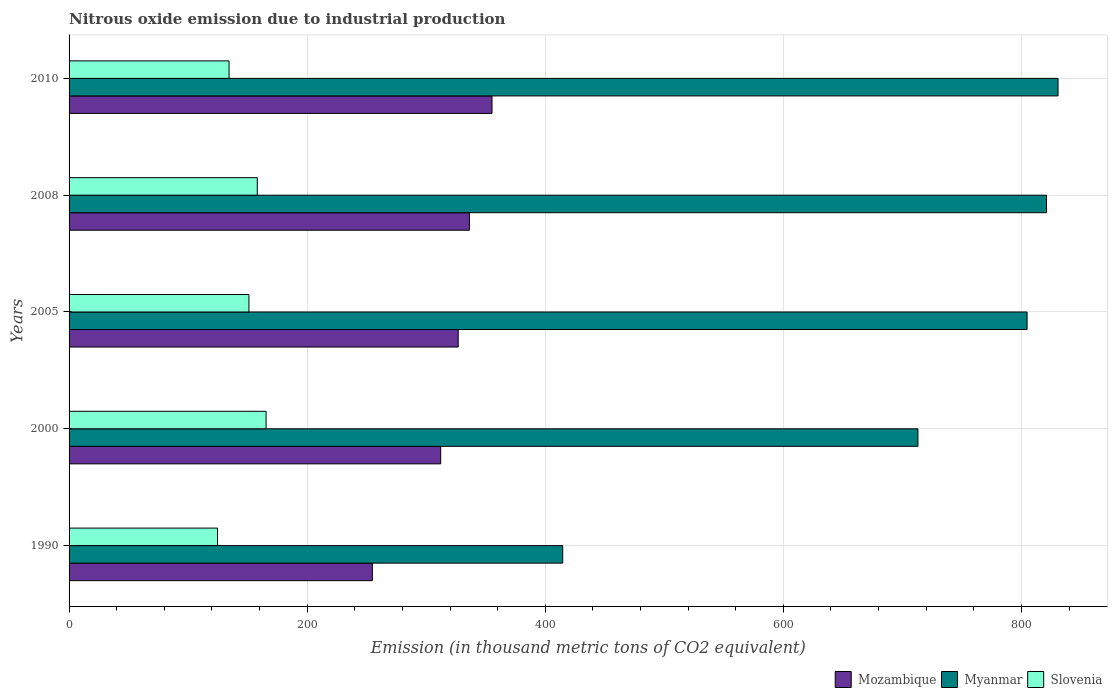How many groups of bars are there?
Your response must be concise. 5. Are the number of bars on each tick of the Y-axis equal?
Provide a short and direct response. Yes. What is the label of the 1st group of bars from the top?
Offer a very short reply. 2010. What is the amount of nitrous oxide emitted in Mozambique in 2005?
Ensure brevity in your answer.  326.9. Across all years, what is the maximum amount of nitrous oxide emitted in Slovenia?
Provide a succinct answer. 165.5. Across all years, what is the minimum amount of nitrous oxide emitted in Myanmar?
Keep it short and to the point. 414.7. In which year was the amount of nitrous oxide emitted in Slovenia maximum?
Your answer should be compact. 2000. In which year was the amount of nitrous oxide emitted in Slovenia minimum?
Your answer should be compact. 1990. What is the total amount of nitrous oxide emitted in Slovenia in the graph?
Your response must be concise. 733.8. What is the difference between the amount of nitrous oxide emitted in Mozambique in 2000 and that in 2008?
Make the answer very short. -24.1. What is the difference between the amount of nitrous oxide emitted in Myanmar in 1990 and the amount of nitrous oxide emitted in Mozambique in 2000?
Your response must be concise. 102.5. What is the average amount of nitrous oxide emitted in Mozambique per year?
Offer a terse response. 317.1. In the year 2005, what is the difference between the amount of nitrous oxide emitted in Slovenia and amount of nitrous oxide emitted in Mozambique?
Keep it short and to the point. -175.8. What is the ratio of the amount of nitrous oxide emitted in Mozambique in 1990 to that in 2008?
Your response must be concise. 0.76. Is the amount of nitrous oxide emitted in Myanmar in 1990 less than that in 2000?
Keep it short and to the point. Yes. Is the difference between the amount of nitrous oxide emitted in Slovenia in 2000 and 2010 greater than the difference between the amount of nitrous oxide emitted in Mozambique in 2000 and 2010?
Offer a very short reply. Yes. What is the difference between the highest and the second highest amount of nitrous oxide emitted in Myanmar?
Your answer should be compact. 9.7. What is the difference between the highest and the lowest amount of nitrous oxide emitted in Slovenia?
Give a very brief answer. 40.8. In how many years, is the amount of nitrous oxide emitted in Slovenia greater than the average amount of nitrous oxide emitted in Slovenia taken over all years?
Your response must be concise. 3. What does the 3rd bar from the top in 2000 represents?
Give a very brief answer. Mozambique. What does the 1st bar from the bottom in 1990 represents?
Your response must be concise. Mozambique. Is it the case that in every year, the sum of the amount of nitrous oxide emitted in Mozambique and amount of nitrous oxide emitted in Myanmar is greater than the amount of nitrous oxide emitted in Slovenia?
Your answer should be very brief. Yes. How many bars are there?
Offer a very short reply. 15. Are all the bars in the graph horizontal?
Keep it short and to the point. Yes. What is the difference between two consecutive major ticks on the X-axis?
Ensure brevity in your answer.  200. Are the values on the major ticks of X-axis written in scientific E-notation?
Offer a terse response. No. How many legend labels are there?
Your response must be concise. 3. What is the title of the graph?
Your answer should be compact. Nitrous oxide emission due to industrial production. What is the label or title of the X-axis?
Your response must be concise. Emission (in thousand metric tons of CO2 equivalent). What is the Emission (in thousand metric tons of CO2 equivalent) in Mozambique in 1990?
Your answer should be very brief. 254.8. What is the Emission (in thousand metric tons of CO2 equivalent) in Myanmar in 1990?
Keep it short and to the point. 414.7. What is the Emission (in thousand metric tons of CO2 equivalent) in Slovenia in 1990?
Make the answer very short. 124.7. What is the Emission (in thousand metric tons of CO2 equivalent) in Mozambique in 2000?
Your answer should be very brief. 312.2. What is the Emission (in thousand metric tons of CO2 equivalent) of Myanmar in 2000?
Provide a succinct answer. 713.1. What is the Emission (in thousand metric tons of CO2 equivalent) of Slovenia in 2000?
Give a very brief answer. 165.5. What is the Emission (in thousand metric tons of CO2 equivalent) in Mozambique in 2005?
Ensure brevity in your answer.  326.9. What is the Emission (in thousand metric tons of CO2 equivalent) of Myanmar in 2005?
Ensure brevity in your answer.  804.8. What is the Emission (in thousand metric tons of CO2 equivalent) of Slovenia in 2005?
Offer a very short reply. 151.1. What is the Emission (in thousand metric tons of CO2 equivalent) of Mozambique in 2008?
Your response must be concise. 336.3. What is the Emission (in thousand metric tons of CO2 equivalent) of Myanmar in 2008?
Give a very brief answer. 821.1. What is the Emission (in thousand metric tons of CO2 equivalent) of Slovenia in 2008?
Give a very brief answer. 158.1. What is the Emission (in thousand metric tons of CO2 equivalent) of Mozambique in 2010?
Your response must be concise. 355.3. What is the Emission (in thousand metric tons of CO2 equivalent) in Myanmar in 2010?
Your answer should be compact. 830.8. What is the Emission (in thousand metric tons of CO2 equivalent) of Slovenia in 2010?
Offer a very short reply. 134.4. Across all years, what is the maximum Emission (in thousand metric tons of CO2 equivalent) of Mozambique?
Offer a terse response. 355.3. Across all years, what is the maximum Emission (in thousand metric tons of CO2 equivalent) of Myanmar?
Keep it short and to the point. 830.8. Across all years, what is the maximum Emission (in thousand metric tons of CO2 equivalent) in Slovenia?
Your response must be concise. 165.5. Across all years, what is the minimum Emission (in thousand metric tons of CO2 equivalent) of Mozambique?
Your answer should be compact. 254.8. Across all years, what is the minimum Emission (in thousand metric tons of CO2 equivalent) of Myanmar?
Provide a short and direct response. 414.7. Across all years, what is the minimum Emission (in thousand metric tons of CO2 equivalent) in Slovenia?
Your response must be concise. 124.7. What is the total Emission (in thousand metric tons of CO2 equivalent) of Mozambique in the graph?
Give a very brief answer. 1585.5. What is the total Emission (in thousand metric tons of CO2 equivalent) of Myanmar in the graph?
Give a very brief answer. 3584.5. What is the total Emission (in thousand metric tons of CO2 equivalent) of Slovenia in the graph?
Offer a very short reply. 733.8. What is the difference between the Emission (in thousand metric tons of CO2 equivalent) of Mozambique in 1990 and that in 2000?
Provide a short and direct response. -57.4. What is the difference between the Emission (in thousand metric tons of CO2 equivalent) in Myanmar in 1990 and that in 2000?
Keep it short and to the point. -298.4. What is the difference between the Emission (in thousand metric tons of CO2 equivalent) of Slovenia in 1990 and that in 2000?
Offer a very short reply. -40.8. What is the difference between the Emission (in thousand metric tons of CO2 equivalent) in Mozambique in 1990 and that in 2005?
Provide a succinct answer. -72.1. What is the difference between the Emission (in thousand metric tons of CO2 equivalent) in Myanmar in 1990 and that in 2005?
Offer a very short reply. -390.1. What is the difference between the Emission (in thousand metric tons of CO2 equivalent) of Slovenia in 1990 and that in 2005?
Your response must be concise. -26.4. What is the difference between the Emission (in thousand metric tons of CO2 equivalent) of Mozambique in 1990 and that in 2008?
Make the answer very short. -81.5. What is the difference between the Emission (in thousand metric tons of CO2 equivalent) of Myanmar in 1990 and that in 2008?
Ensure brevity in your answer.  -406.4. What is the difference between the Emission (in thousand metric tons of CO2 equivalent) of Slovenia in 1990 and that in 2008?
Offer a very short reply. -33.4. What is the difference between the Emission (in thousand metric tons of CO2 equivalent) of Mozambique in 1990 and that in 2010?
Your response must be concise. -100.5. What is the difference between the Emission (in thousand metric tons of CO2 equivalent) of Myanmar in 1990 and that in 2010?
Your answer should be very brief. -416.1. What is the difference between the Emission (in thousand metric tons of CO2 equivalent) of Slovenia in 1990 and that in 2010?
Keep it short and to the point. -9.7. What is the difference between the Emission (in thousand metric tons of CO2 equivalent) in Mozambique in 2000 and that in 2005?
Give a very brief answer. -14.7. What is the difference between the Emission (in thousand metric tons of CO2 equivalent) of Myanmar in 2000 and that in 2005?
Provide a short and direct response. -91.7. What is the difference between the Emission (in thousand metric tons of CO2 equivalent) of Mozambique in 2000 and that in 2008?
Offer a terse response. -24.1. What is the difference between the Emission (in thousand metric tons of CO2 equivalent) of Myanmar in 2000 and that in 2008?
Your response must be concise. -108. What is the difference between the Emission (in thousand metric tons of CO2 equivalent) in Mozambique in 2000 and that in 2010?
Give a very brief answer. -43.1. What is the difference between the Emission (in thousand metric tons of CO2 equivalent) in Myanmar in 2000 and that in 2010?
Offer a terse response. -117.7. What is the difference between the Emission (in thousand metric tons of CO2 equivalent) in Slovenia in 2000 and that in 2010?
Your response must be concise. 31.1. What is the difference between the Emission (in thousand metric tons of CO2 equivalent) in Mozambique in 2005 and that in 2008?
Provide a short and direct response. -9.4. What is the difference between the Emission (in thousand metric tons of CO2 equivalent) of Myanmar in 2005 and that in 2008?
Keep it short and to the point. -16.3. What is the difference between the Emission (in thousand metric tons of CO2 equivalent) in Mozambique in 2005 and that in 2010?
Offer a terse response. -28.4. What is the difference between the Emission (in thousand metric tons of CO2 equivalent) in Slovenia in 2005 and that in 2010?
Your answer should be compact. 16.7. What is the difference between the Emission (in thousand metric tons of CO2 equivalent) in Myanmar in 2008 and that in 2010?
Your answer should be very brief. -9.7. What is the difference between the Emission (in thousand metric tons of CO2 equivalent) of Slovenia in 2008 and that in 2010?
Provide a short and direct response. 23.7. What is the difference between the Emission (in thousand metric tons of CO2 equivalent) in Mozambique in 1990 and the Emission (in thousand metric tons of CO2 equivalent) in Myanmar in 2000?
Offer a terse response. -458.3. What is the difference between the Emission (in thousand metric tons of CO2 equivalent) in Mozambique in 1990 and the Emission (in thousand metric tons of CO2 equivalent) in Slovenia in 2000?
Keep it short and to the point. 89.3. What is the difference between the Emission (in thousand metric tons of CO2 equivalent) in Myanmar in 1990 and the Emission (in thousand metric tons of CO2 equivalent) in Slovenia in 2000?
Give a very brief answer. 249.2. What is the difference between the Emission (in thousand metric tons of CO2 equivalent) in Mozambique in 1990 and the Emission (in thousand metric tons of CO2 equivalent) in Myanmar in 2005?
Your answer should be compact. -550. What is the difference between the Emission (in thousand metric tons of CO2 equivalent) of Mozambique in 1990 and the Emission (in thousand metric tons of CO2 equivalent) of Slovenia in 2005?
Your answer should be very brief. 103.7. What is the difference between the Emission (in thousand metric tons of CO2 equivalent) of Myanmar in 1990 and the Emission (in thousand metric tons of CO2 equivalent) of Slovenia in 2005?
Give a very brief answer. 263.6. What is the difference between the Emission (in thousand metric tons of CO2 equivalent) in Mozambique in 1990 and the Emission (in thousand metric tons of CO2 equivalent) in Myanmar in 2008?
Offer a terse response. -566.3. What is the difference between the Emission (in thousand metric tons of CO2 equivalent) in Mozambique in 1990 and the Emission (in thousand metric tons of CO2 equivalent) in Slovenia in 2008?
Your response must be concise. 96.7. What is the difference between the Emission (in thousand metric tons of CO2 equivalent) of Myanmar in 1990 and the Emission (in thousand metric tons of CO2 equivalent) of Slovenia in 2008?
Give a very brief answer. 256.6. What is the difference between the Emission (in thousand metric tons of CO2 equivalent) in Mozambique in 1990 and the Emission (in thousand metric tons of CO2 equivalent) in Myanmar in 2010?
Provide a short and direct response. -576. What is the difference between the Emission (in thousand metric tons of CO2 equivalent) of Mozambique in 1990 and the Emission (in thousand metric tons of CO2 equivalent) of Slovenia in 2010?
Offer a terse response. 120.4. What is the difference between the Emission (in thousand metric tons of CO2 equivalent) of Myanmar in 1990 and the Emission (in thousand metric tons of CO2 equivalent) of Slovenia in 2010?
Your response must be concise. 280.3. What is the difference between the Emission (in thousand metric tons of CO2 equivalent) of Mozambique in 2000 and the Emission (in thousand metric tons of CO2 equivalent) of Myanmar in 2005?
Keep it short and to the point. -492.6. What is the difference between the Emission (in thousand metric tons of CO2 equivalent) in Mozambique in 2000 and the Emission (in thousand metric tons of CO2 equivalent) in Slovenia in 2005?
Your answer should be very brief. 161.1. What is the difference between the Emission (in thousand metric tons of CO2 equivalent) of Myanmar in 2000 and the Emission (in thousand metric tons of CO2 equivalent) of Slovenia in 2005?
Make the answer very short. 562. What is the difference between the Emission (in thousand metric tons of CO2 equivalent) in Mozambique in 2000 and the Emission (in thousand metric tons of CO2 equivalent) in Myanmar in 2008?
Offer a terse response. -508.9. What is the difference between the Emission (in thousand metric tons of CO2 equivalent) of Mozambique in 2000 and the Emission (in thousand metric tons of CO2 equivalent) of Slovenia in 2008?
Your answer should be very brief. 154.1. What is the difference between the Emission (in thousand metric tons of CO2 equivalent) in Myanmar in 2000 and the Emission (in thousand metric tons of CO2 equivalent) in Slovenia in 2008?
Provide a short and direct response. 555. What is the difference between the Emission (in thousand metric tons of CO2 equivalent) of Mozambique in 2000 and the Emission (in thousand metric tons of CO2 equivalent) of Myanmar in 2010?
Ensure brevity in your answer.  -518.6. What is the difference between the Emission (in thousand metric tons of CO2 equivalent) of Mozambique in 2000 and the Emission (in thousand metric tons of CO2 equivalent) of Slovenia in 2010?
Your answer should be compact. 177.8. What is the difference between the Emission (in thousand metric tons of CO2 equivalent) of Myanmar in 2000 and the Emission (in thousand metric tons of CO2 equivalent) of Slovenia in 2010?
Offer a very short reply. 578.7. What is the difference between the Emission (in thousand metric tons of CO2 equivalent) of Mozambique in 2005 and the Emission (in thousand metric tons of CO2 equivalent) of Myanmar in 2008?
Keep it short and to the point. -494.2. What is the difference between the Emission (in thousand metric tons of CO2 equivalent) in Mozambique in 2005 and the Emission (in thousand metric tons of CO2 equivalent) in Slovenia in 2008?
Your answer should be very brief. 168.8. What is the difference between the Emission (in thousand metric tons of CO2 equivalent) of Myanmar in 2005 and the Emission (in thousand metric tons of CO2 equivalent) of Slovenia in 2008?
Your answer should be compact. 646.7. What is the difference between the Emission (in thousand metric tons of CO2 equivalent) of Mozambique in 2005 and the Emission (in thousand metric tons of CO2 equivalent) of Myanmar in 2010?
Provide a succinct answer. -503.9. What is the difference between the Emission (in thousand metric tons of CO2 equivalent) in Mozambique in 2005 and the Emission (in thousand metric tons of CO2 equivalent) in Slovenia in 2010?
Keep it short and to the point. 192.5. What is the difference between the Emission (in thousand metric tons of CO2 equivalent) in Myanmar in 2005 and the Emission (in thousand metric tons of CO2 equivalent) in Slovenia in 2010?
Your answer should be very brief. 670.4. What is the difference between the Emission (in thousand metric tons of CO2 equivalent) of Mozambique in 2008 and the Emission (in thousand metric tons of CO2 equivalent) of Myanmar in 2010?
Offer a very short reply. -494.5. What is the difference between the Emission (in thousand metric tons of CO2 equivalent) in Mozambique in 2008 and the Emission (in thousand metric tons of CO2 equivalent) in Slovenia in 2010?
Your response must be concise. 201.9. What is the difference between the Emission (in thousand metric tons of CO2 equivalent) of Myanmar in 2008 and the Emission (in thousand metric tons of CO2 equivalent) of Slovenia in 2010?
Offer a very short reply. 686.7. What is the average Emission (in thousand metric tons of CO2 equivalent) of Mozambique per year?
Your answer should be compact. 317.1. What is the average Emission (in thousand metric tons of CO2 equivalent) of Myanmar per year?
Offer a very short reply. 716.9. What is the average Emission (in thousand metric tons of CO2 equivalent) of Slovenia per year?
Give a very brief answer. 146.76. In the year 1990, what is the difference between the Emission (in thousand metric tons of CO2 equivalent) of Mozambique and Emission (in thousand metric tons of CO2 equivalent) of Myanmar?
Ensure brevity in your answer.  -159.9. In the year 1990, what is the difference between the Emission (in thousand metric tons of CO2 equivalent) in Mozambique and Emission (in thousand metric tons of CO2 equivalent) in Slovenia?
Give a very brief answer. 130.1. In the year 1990, what is the difference between the Emission (in thousand metric tons of CO2 equivalent) of Myanmar and Emission (in thousand metric tons of CO2 equivalent) of Slovenia?
Your answer should be compact. 290. In the year 2000, what is the difference between the Emission (in thousand metric tons of CO2 equivalent) in Mozambique and Emission (in thousand metric tons of CO2 equivalent) in Myanmar?
Your response must be concise. -400.9. In the year 2000, what is the difference between the Emission (in thousand metric tons of CO2 equivalent) of Mozambique and Emission (in thousand metric tons of CO2 equivalent) of Slovenia?
Provide a succinct answer. 146.7. In the year 2000, what is the difference between the Emission (in thousand metric tons of CO2 equivalent) in Myanmar and Emission (in thousand metric tons of CO2 equivalent) in Slovenia?
Give a very brief answer. 547.6. In the year 2005, what is the difference between the Emission (in thousand metric tons of CO2 equivalent) in Mozambique and Emission (in thousand metric tons of CO2 equivalent) in Myanmar?
Provide a short and direct response. -477.9. In the year 2005, what is the difference between the Emission (in thousand metric tons of CO2 equivalent) of Mozambique and Emission (in thousand metric tons of CO2 equivalent) of Slovenia?
Your answer should be compact. 175.8. In the year 2005, what is the difference between the Emission (in thousand metric tons of CO2 equivalent) in Myanmar and Emission (in thousand metric tons of CO2 equivalent) in Slovenia?
Provide a short and direct response. 653.7. In the year 2008, what is the difference between the Emission (in thousand metric tons of CO2 equivalent) in Mozambique and Emission (in thousand metric tons of CO2 equivalent) in Myanmar?
Keep it short and to the point. -484.8. In the year 2008, what is the difference between the Emission (in thousand metric tons of CO2 equivalent) of Mozambique and Emission (in thousand metric tons of CO2 equivalent) of Slovenia?
Make the answer very short. 178.2. In the year 2008, what is the difference between the Emission (in thousand metric tons of CO2 equivalent) in Myanmar and Emission (in thousand metric tons of CO2 equivalent) in Slovenia?
Offer a terse response. 663. In the year 2010, what is the difference between the Emission (in thousand metric tons of CO2 equivalent) of Mozambique and Emission (in thousand metric tons of CO2 equivalent) of Myanmar?
Provide a succinct answer. -475.5. In the year 2010, what is the difference between the Emission (in thousand metric tons of CO2 equivalent) in Mozambique and Emission (in thousand metric tons of CO2 equivalent) in Slovenia?
Provide a short and direct response. 220.9. In the year 2010, what is the difference between the Emission (in thousand metric tons of CO2 equivalent) of Myanmar and Emission (in thousand metric tons of CO2 equivalent) of Slovenia?
Give a very brief answer. 696.4. What is the ratio of the Emission (in thousand metric tons of CO2 equivalent) of Mozambique in 1990 to that in 2000?
Your response must be concise. 0.82. What is the ratio of the Emission (in thousand metric tons of CO2 equivalent) in Myanmar in 1990 to that in 2000?
Your answer should be compact. 0.58. What is the ratio of the Emission (in thousand metric tons of CO2 equivalent) of Slovenia in 1990 to that in 2000?
Offer a terse response. 0.75. What is the ratio of the Emission (in thousand metric tons of CO2 equivalent) in Mozambique in 1990 to that in 2005?
Your answer should be compact. 0.78. What is the ratio of the Emission (in thousand metric tons of CO2 equivalent) of Myanmar in 1990 to that in 2005?
Provide a succinct answer. 0.52. What is the ratio of the Emission (in thousand metric tons of CO2 equivalent) in Slovenia in 1990 to that in 2005?
Your response must be concise. 0.83. What is the ratio of the Emission (in thousand metric tons of CO2 equivalent) of Mozambique in 1990 to that in 2008?
Your answer should be very brief. 0.76. What is the ratio of the Emission (in thousand metric tons of CO2 equivalent) in Myanmar in 1990 to that in 2008?
Offer a terse response. 0.51. What is the ratio of the Emission (in thousand metric tons of CO2 equivalent) of Slovenia in 1990 to that in 2008?
Your answer should be compact. 0.79. What is the ratio of the Emission (in thousand metric tons of CO2 equivalent) in Mozambique in 1990 to that in 2010?
Your response must be concise. 0.72. What is the ratio of the Emission (in thousand metric tons of CO2 equivalent) of Myanmar in 1990 to that in 2010?
Give a very brief answer. 0.5. What is the ratio of the Emission (in thousand metric tons of CO2 equivalent) in Slovenia in 1990 to that in 2010?
Give a very brief answer. 0.93. What is the ratio of the Emission (in thousand metric tons of CO2 equivalent) in Mozambique in 2000 to that in 2005?
Ensure brevity in your answer.  0.95. What is the ratio of the Emission (in thousand metric tons of CO2 equivalent) in Myanmar in 2000 to that in 2005?
Your answer should be compact. 0.89. What is the ratio of the Emission (in thousand metric tons of CO2 equivalent) in Slovenia in 2000 to that in 2005?
Make the answer very short. 1.1. What is the ratio of the Emission (in thousand metric tons of CO2 equivalent) in Mozambique in 2000 to that in 2008?
Provide a short and direct response. 0.93. What is the ratio of the Emission (in thousand metric tons of CO2 equivalent) in Myanmar in 2000 to that in 2008?
Offer a terse response. 0.87. What is the ratio of the Emission (in thousand metric tons of CO2 equivalent) of Slovenia in 2000 to that in 2008?
Offer a very short reply. 1.05. What is the ratio of the Emission (in thousand metric tons of CO2 equivalent) of Mozambique in 2000 to that in 2010?
Your response must be concise. 0.88. What is the ratio of the Emission (in thousand metric tons of CO2 equivalent) of Myanmar in 2000 to that in 2010?
Your answer should be very brief. 0.86. What is the ratio of the Emission (in thousand metric tons of CO2 equivalent) in Slovenia in 2000 to that in 2010?
Ensure brevity in your answer.  1.23. What is the ratio of the Emission (in thousand metric tons of CO2 equivalent) of Myanmar in 2005 to that in 2008?
Your response must be concise. 0.98. What is the ratio of the Emission (in thousand metric tons of CO2 equivalent) of Slovenia in 2005 to that in 2008?
Offer a very short reply. 0.96. What is the ratio of the Emission (in thousand metric tons of CO2 equivalent) in Mozambique in 2005 to that in 2010?
Give a very brief answer. 0.92. What is the ratio of the Emission (in thousand metric tons of CO2 equivalent) of Myanmar in 2005 to that in 2010?
Your response must be concise. 0.97. What is the ratio of the Emission (in thousand metric tons of CO2 equivalent) in Slovenia in 2005 to that in 2010?
Your response must be concise. 1.12. What is the ratio of the Emission (in thousand metric tons of CO2 equivalent) of Mozambique in 2008 to that in 2010?
Your answer should be very brief. 0.95. What is the ratio of the Emission (in thousand metric tons of CO2 equivalent) of Myanmar in 2008 to that in 2010?
Your answer should be compact. 0.99. What is the ratio of the Emission (in thousand metric tons of CO2 equivalent) of Slovenia in 2008 to that in 2010?
Give a very brief answer. 1.18. What is the difference between the highest and the second highest Emission (in thousand metric tons of CO2 equivalent) in Myanmar?
Your response must be concise. 9.7. What is the difference between the highest and the lowest Emission (in thousand metric tons of CO2 equivalent) in Mozambique?
Ensure brevity in your answer.  100.5. What is the difference between the highest and the lowest Emission (in thousand metric tons of CO2 equivalent) of Myanmar?
Your response must be concise. 416.1. What is the difference between the highest and the lowest Emission (in thousand metric tons of CO2 equivalent) in Slovenia?
Your answer should be very brief. 40.8. 